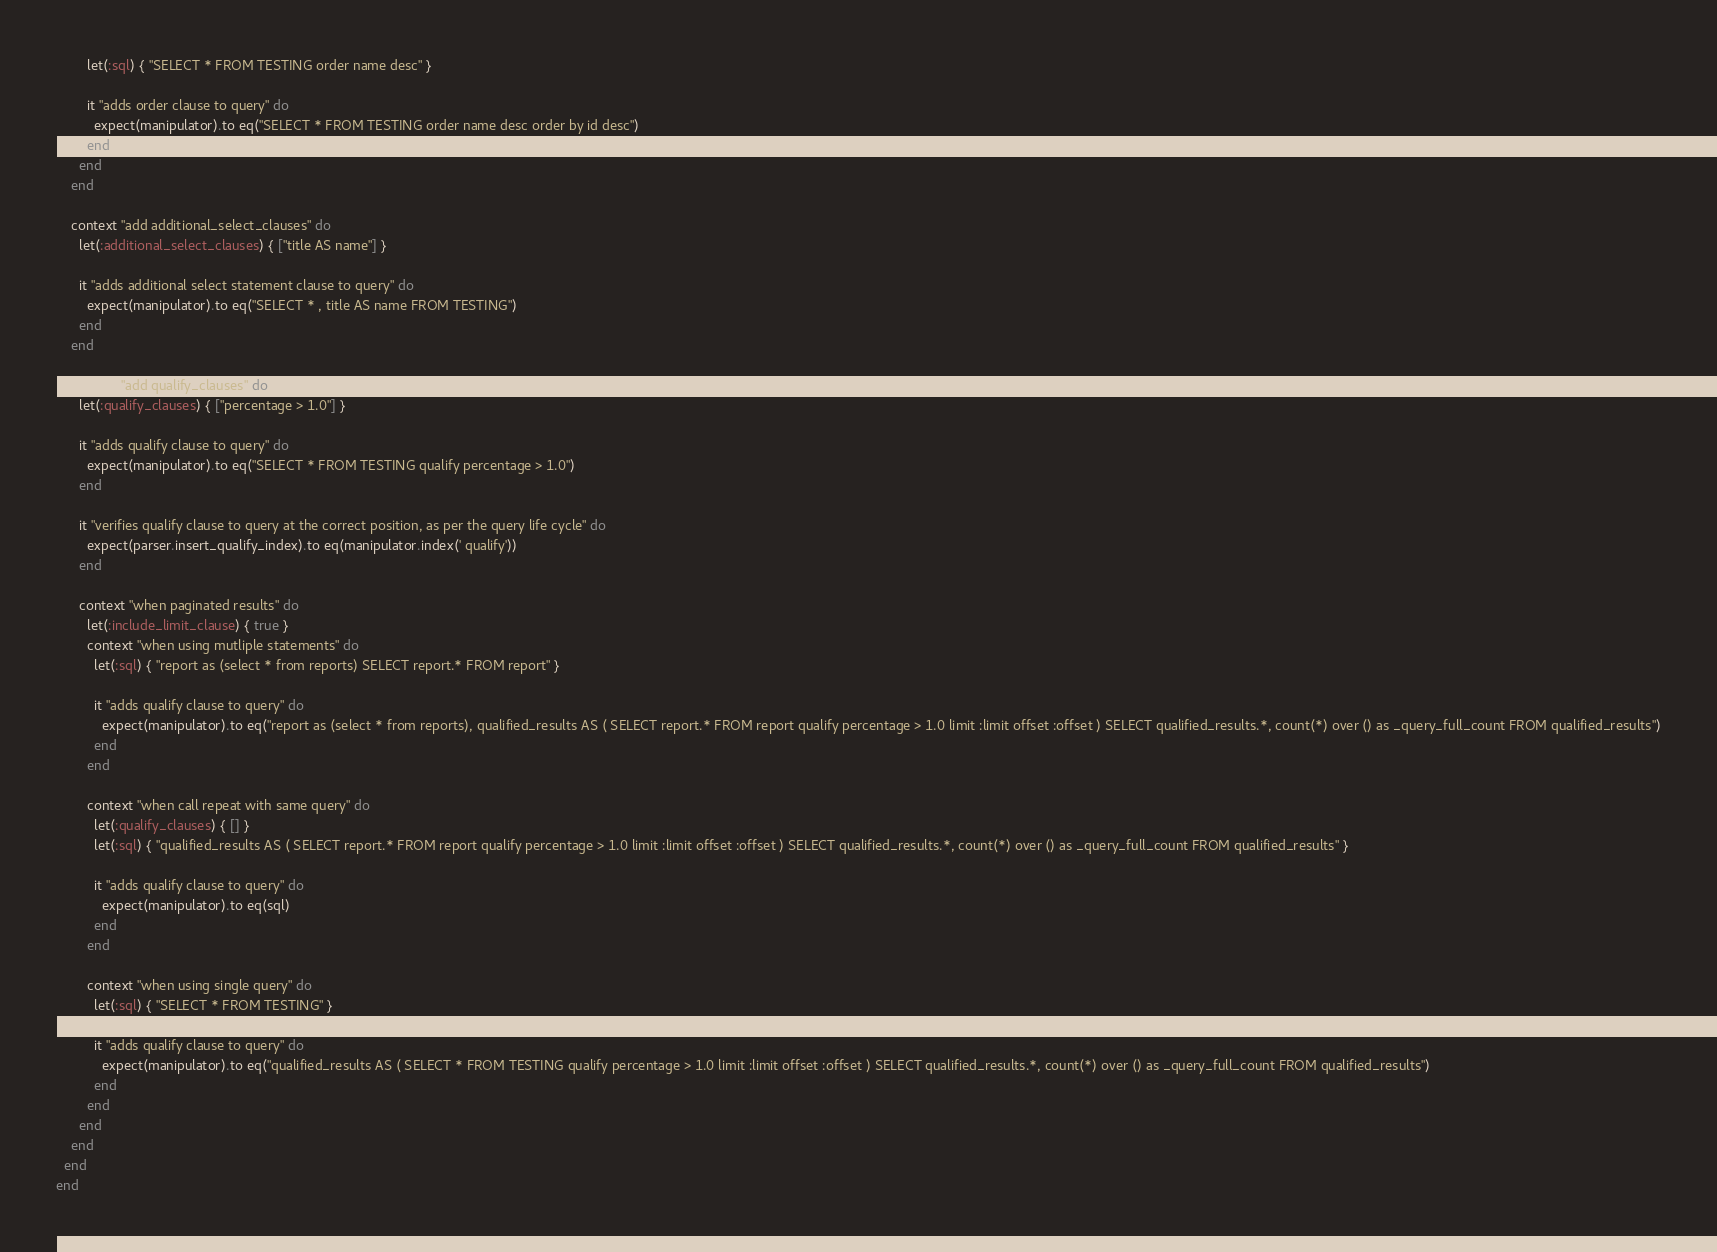Convert code to text. <code><loc_0><loc_0><loc_500><loc_500><_Ruby_>        let(:sql) { "SELECT * FROM TESTING order name desc" }

        it "adds order clause to query" do
          expect(manipulator).to eq("SELECT * FROM TESTING order name desc order by id desc")
        end
      end
    end

    context "add additional_select_clauses" do
      let(:additional_select_clauses) { ["title AS name"] }

      it "adds additional select statement clause to query" do
        expect(manipulator).to eq("SELECT * , title AS name FROM TESTING")
      end
    end

    context "add qualify_clauses" do
      let(:qualify_clauses) { ["percentage > 1.0"] }

      it "adds qualify clause to query" do
        expect(manipulator).to eq("SELECT * FROM TESTING qualify percentage > 1.0")
      end

      it "verifies qualify clause to query at the correct position, as per the query life cycle" do
        expect(parser.insert_qualify_index).to eq(manipulator.index(' qualify'))
      end

      context "when paginated results" do
        let(:include_limit_clause) { true }
        context "when using mutliple statements" do
          let(:sql) { "report as (select * from reports) SELECT report.* FROM report" }

          it "adds qualify clause to query" do
            expect(manipulator).to eq("report as (select * from reports), qualified_results AS ( SELECT report.* FROM report qualify percentage > 1.0 limit :limit offset :offset ) SELECT qualified_results.*, count(*) over () as _query_full_count FROM qualified_results")
          end
        end

        context "when call repeat with same query" do
          let(:qualify_clauses) { [] }
          let(:sql) { "qualified_results AS ( SELECT report.* FROM report qualify percentage > 1.0 limit :limit offset :offset ) SELECT qualified_results.*, count(*) over () as _query_full_count FROM qualified_results" }

          it "adds qualify clause to query" do
            expect(manipulator).to eq(sql)
          end
        end

        context "when using single query" do
          let(:sql) { "SELECT * FROM TESTING" }

          it "adds qualify clause to query" do
            expect(manipulator).to eq("qualified_results AS ( SELECT * FROM TESTING qualify percentage > 1.0 limit :limit offset :offset ) SELECT qualified_results.*, count(*) over () as _query_full_count FROM qualified_results")
          end
        end
      end
    end
  end
end
</code> 